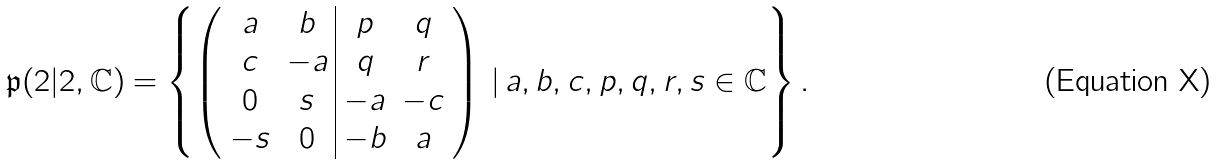<formula> <loc_0><loc_0><loc_500><loc_500>\mathfrak { p } ( 2 | 2 , \mathbb { C } ) = \left \{ \left ( \begin{array} { c c | c c } a & b & p & q \\ c & - a & q & r \\ 0 & s & - a & - c \\ - s & 0 & - b & a \end{array} \right ) \, | \, a , b , c , p , q , r , s \in \mathbb { C } \right \} .</formula> 